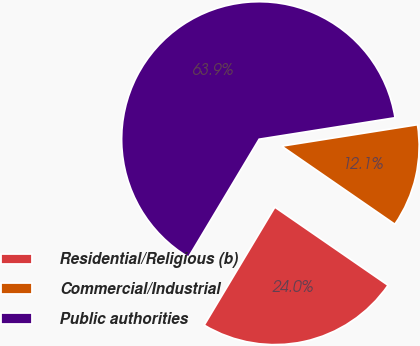Convert chart. <chart><loc_0><loc_0><loc_500><loc_500><pie_chart><fcel>Residential/Religious (b)<fcel>Commercial/Industrial<fcel>Public authorities<nl><fcel>23.97%<fcel>12.11%<fcel>63.92%<nl></chart> 